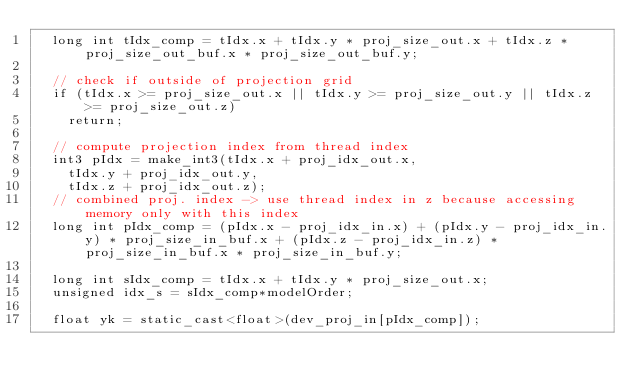<code> <loc_0><loc_0><loc_500><loc_500><_Cuda_>  long int tIdx_comp = tIdx.x + tIdx.y * proj_size_out.x + tIdx.z * proj_size_out_buf.x * proj_size_out_buf.y;

  // check if outside of projection grid
  if (tIdx.x >= proj_size_out.x || tIdx.y >= proj_size_out.y || tIdx.z >= proj_size_out.z)
    return;

  // compute projection index from thread index
  int3 pIdx = make_int3(tIdx.x + proj_idx_out.x,
    tIdx.y + proj_idx_out.y,
    tIdx.z + proj_idx_out.z);
  // combined proj. index -> use thread index in z because accessing memory only with this index
  long int pIdx_comp = (pIdx.x - proj_idx_in.x) + (pIdx.y - proj_idx_in.y) * proj_size_in_buf.x + (pIdx.z - proj_idx_in.z) * proj_size_in_buf.x * proj_size_in_buf.y;

  long int sIdx_comp = tIdx.x + tIdx.y * proj_size_out.x;
  unsigned idx_s = sIdx_comp*modelOrder;

  float yk = static_cast<float>(dev_proj_in[pIdx_comp]);</code> 